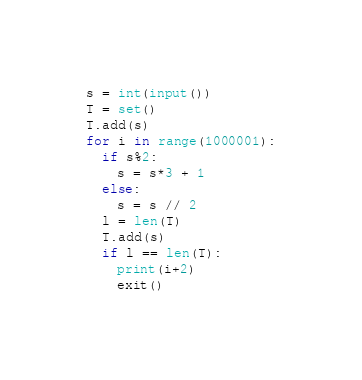Convert code to text. <code><loc_0><loc_0><loc_500><loc_500><_Python_>s = int(input())
T = set()
T.add(s)
for i in range(1000001):
  if s%2:
    s = s*3 + 1
  else:
    s = s // 2
  l = len(T)
  T.add(s)
  if l == len(T):
    print(i+2)
    exit()</code> 